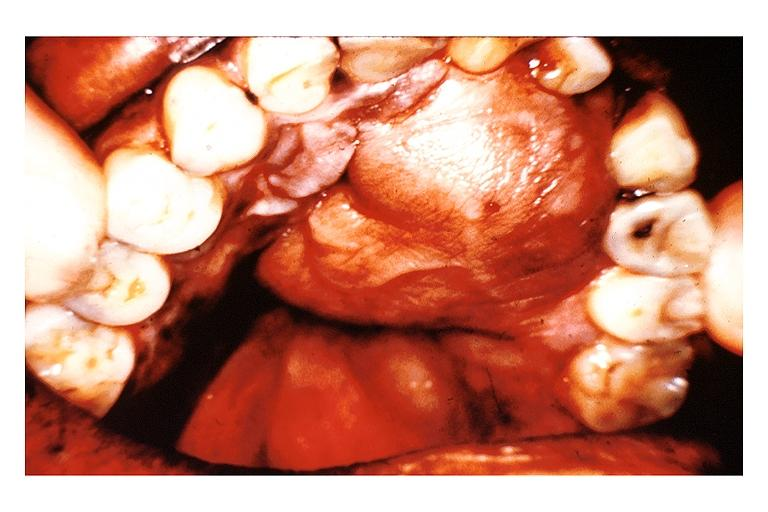does muscle show neurofibroma?
Answer the question using a single word or phrase. No 